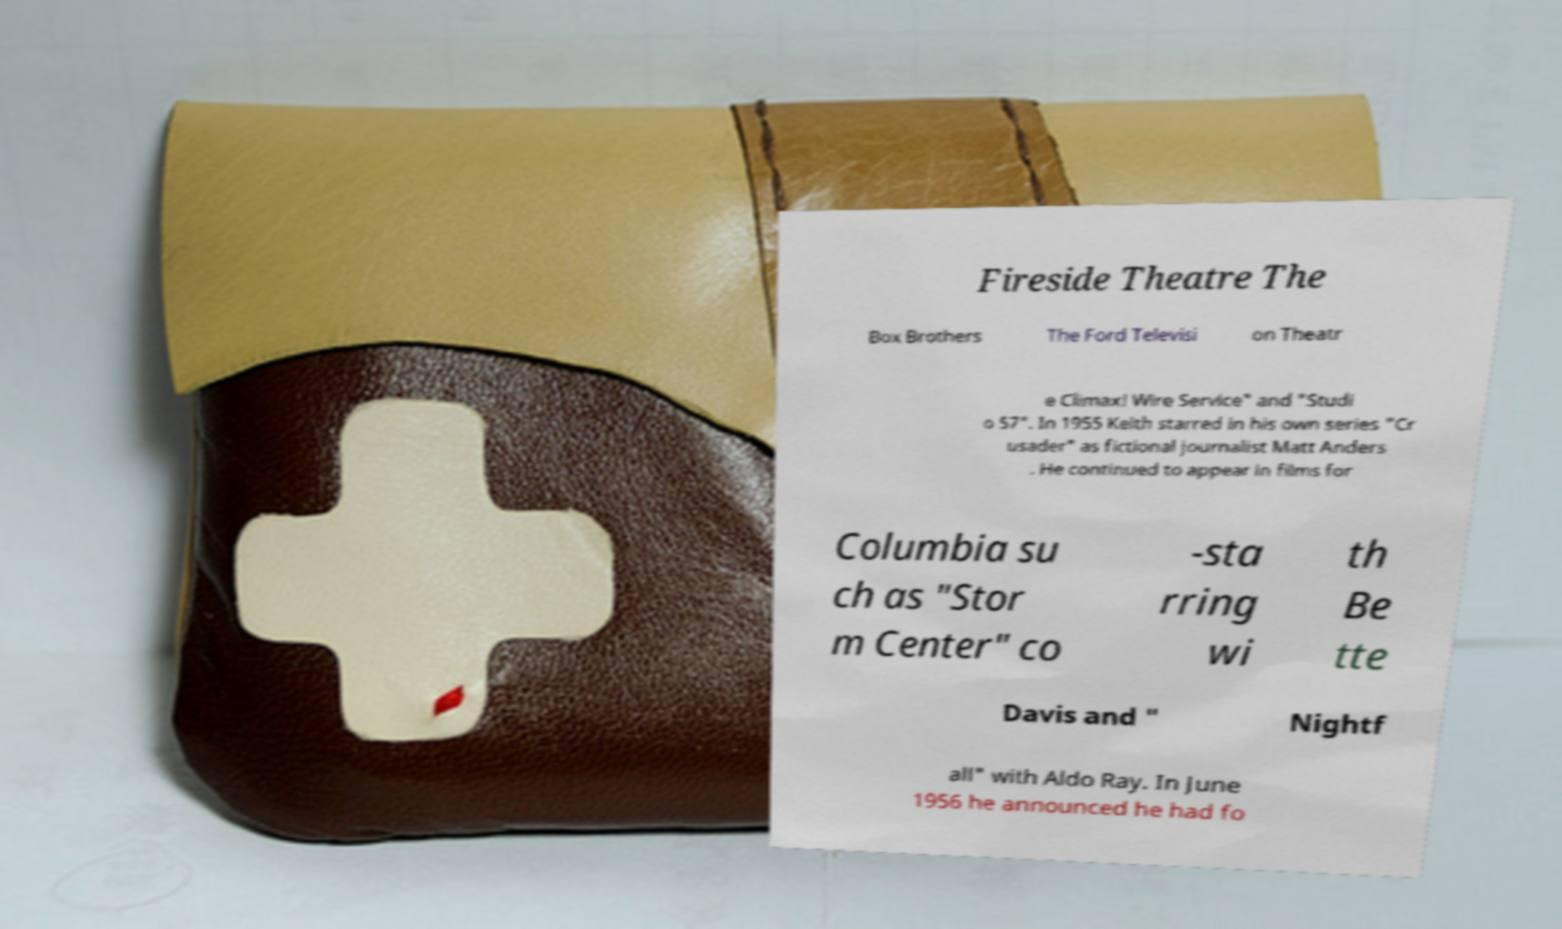Could you extract and type out the text from this image? Fireside Theatre The Box Brothers The Ford Televisi on Theatr e Climax! Wire Service" and "Studi o 57". In 1955 Keith starred in his own series "Cr usader" as fictional journalist Matt Anders . He continued to appear in films for Columbia su ch as "Stor m Center" co -sta rring wi th Be tte Davis and " Nightf all" with Aldo Ray. In June 1956 he announced he had fo 